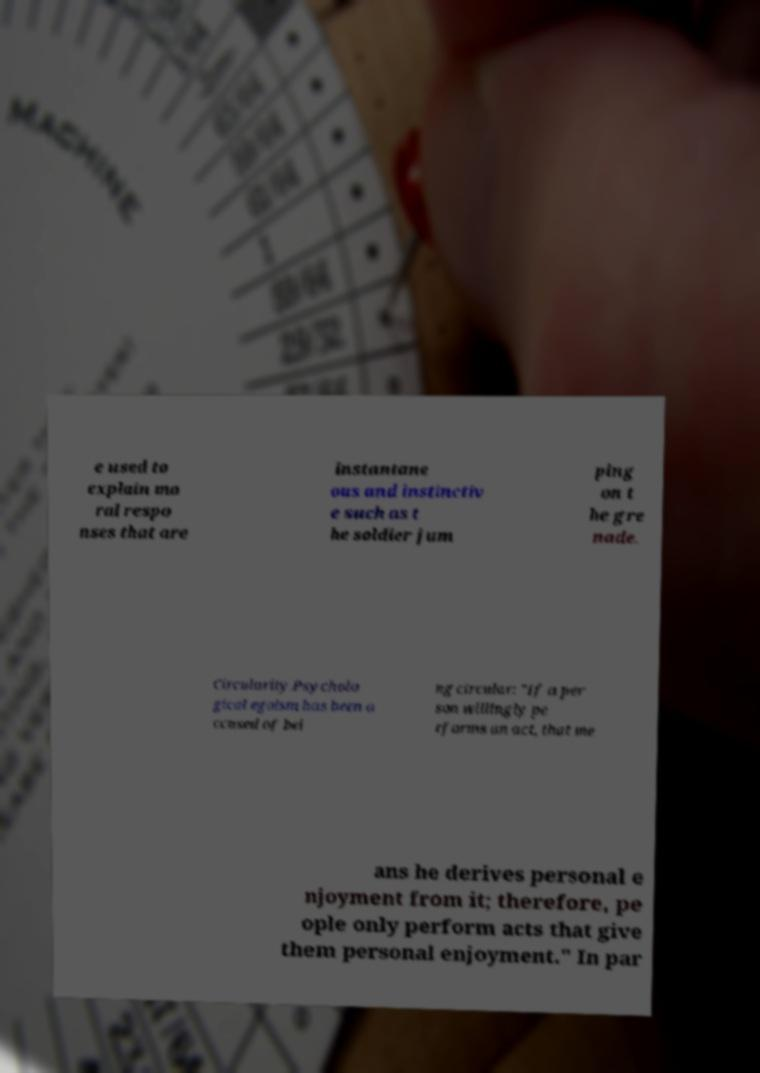What messages or text are displayed in this image? I need them in a readable, typed format. e used to explain mo ral respo nses that are instantane ous and instinctiv e such as t he soldier jum ping on t he gre nade. Circularity.Psycholo gical egoism has been a ccused of bei ng circular: "If a per son willingly pe rforms an act, that me ans he derives personal e njoyment from it; therefore, pe ople only perform acts that give them personal enjoyment." In par 